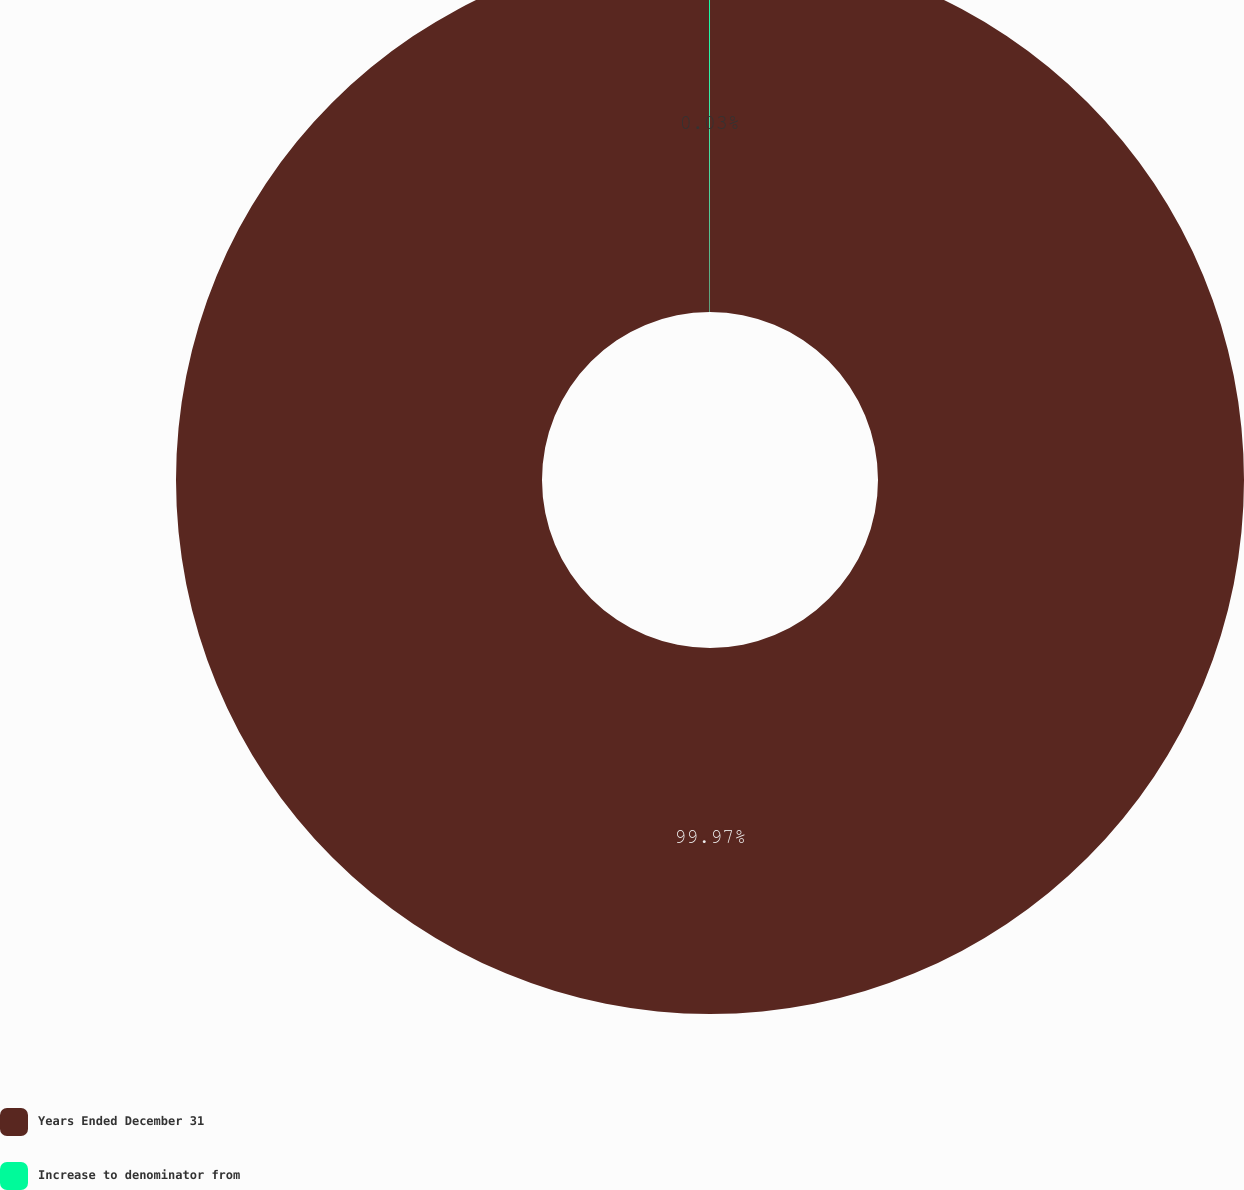Convert chart to OTSL. <chart><loc_0><loc_0><loc_500><loc_500><pie_chart><fcel>Years Ended December 31<fcel>Increase to denominator from<nl><fcel>99.97%<fcel>0.03%<nl></chart> 